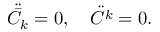Convert formula to latex. <formula><loc_0><loc_0><loc_500><loc_500>\ddot { { \bar { C } } _ { k } } = 0 , \quad \ddot { { C } ^ { k } } = 0 .</formula> 